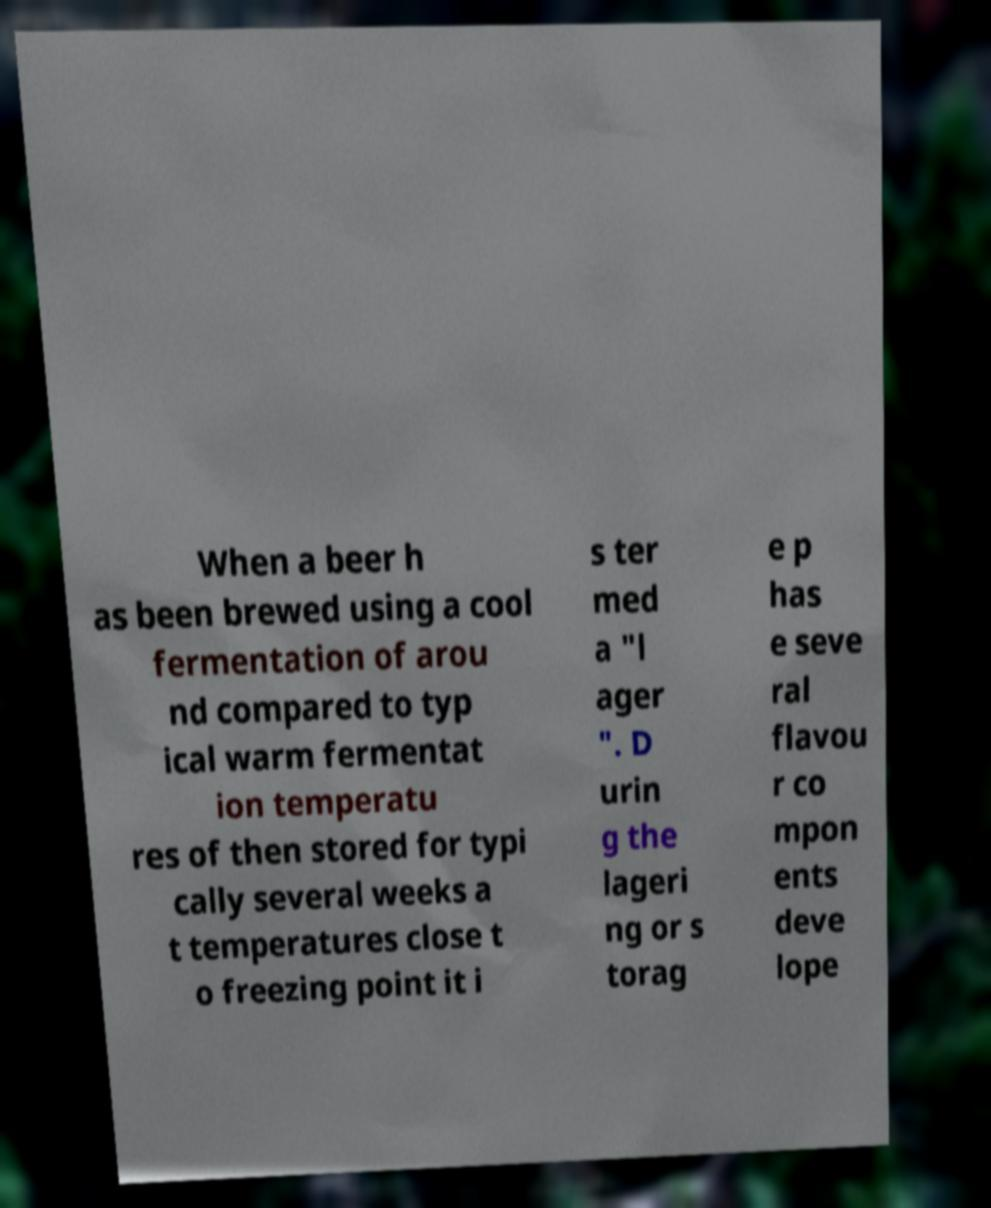There's text embedded in this image that I need extracted. Can you transcribe it verbatim? When a beer h as been brewed using a cool fermentation of arou nd compared to typ ical warm fermentat ion temperatu res of then stored for typi cally several weeks a t temperatures close t o freezing point it i s ter med a "l ager ". D urin g the lageri ng or s torag e p has e seve ral flavou r co mpon ents deve lope 